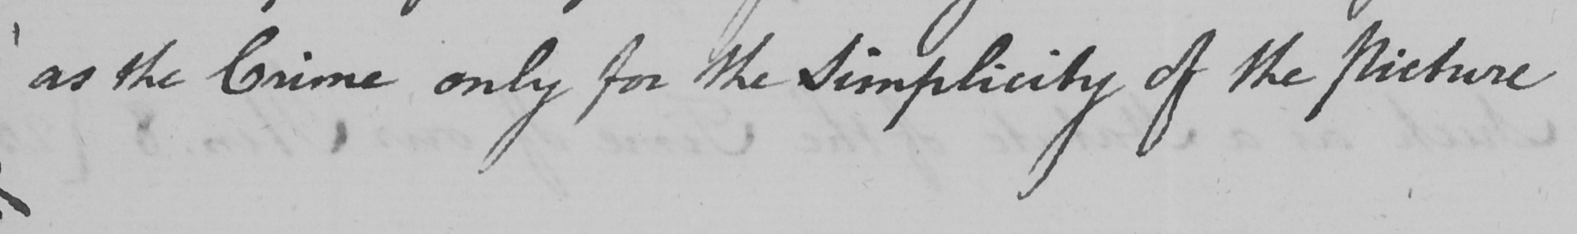What is written in this line of handwriting? as the Crime only for the Simplicity of the Picture 